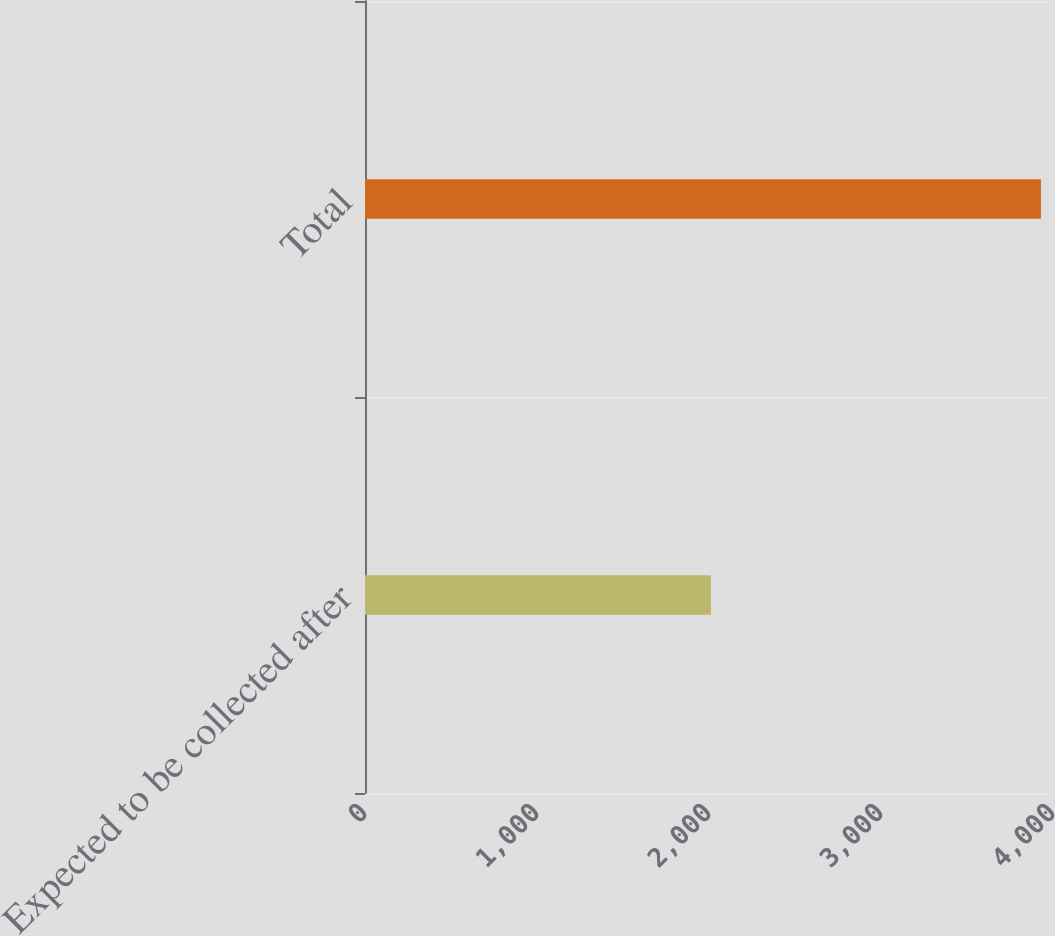Convert chart. <chart><loc_0><loc_0><loc_500><loc_500><bar_chart><fcel>Expected to be collected after<fcel>Total<nl><fcel>2011<fcel>3930<nl></chart> 